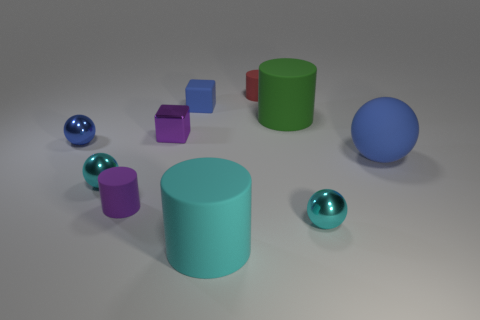Subtract all metal balls. How many balls are left? 1 Subtract all small blue rubber blocks. Subtract all big brown spheres. How many objects are left? 9 Add 3 big objects. How many big objects are left? 6 Add 1 red matte things. How many red matte things exist? 2 Subtract all green cylinders. How many cylinders are left? 3 Subtract 1 cyan balls. How many objects are left? 9 Subtract all balls. How many objects are left? 6 Subtract all blue cylinders. Subtract all red cubes. How many cylinders are left? 4 Subtract all blue blocks. How many blue balls are left? 2 